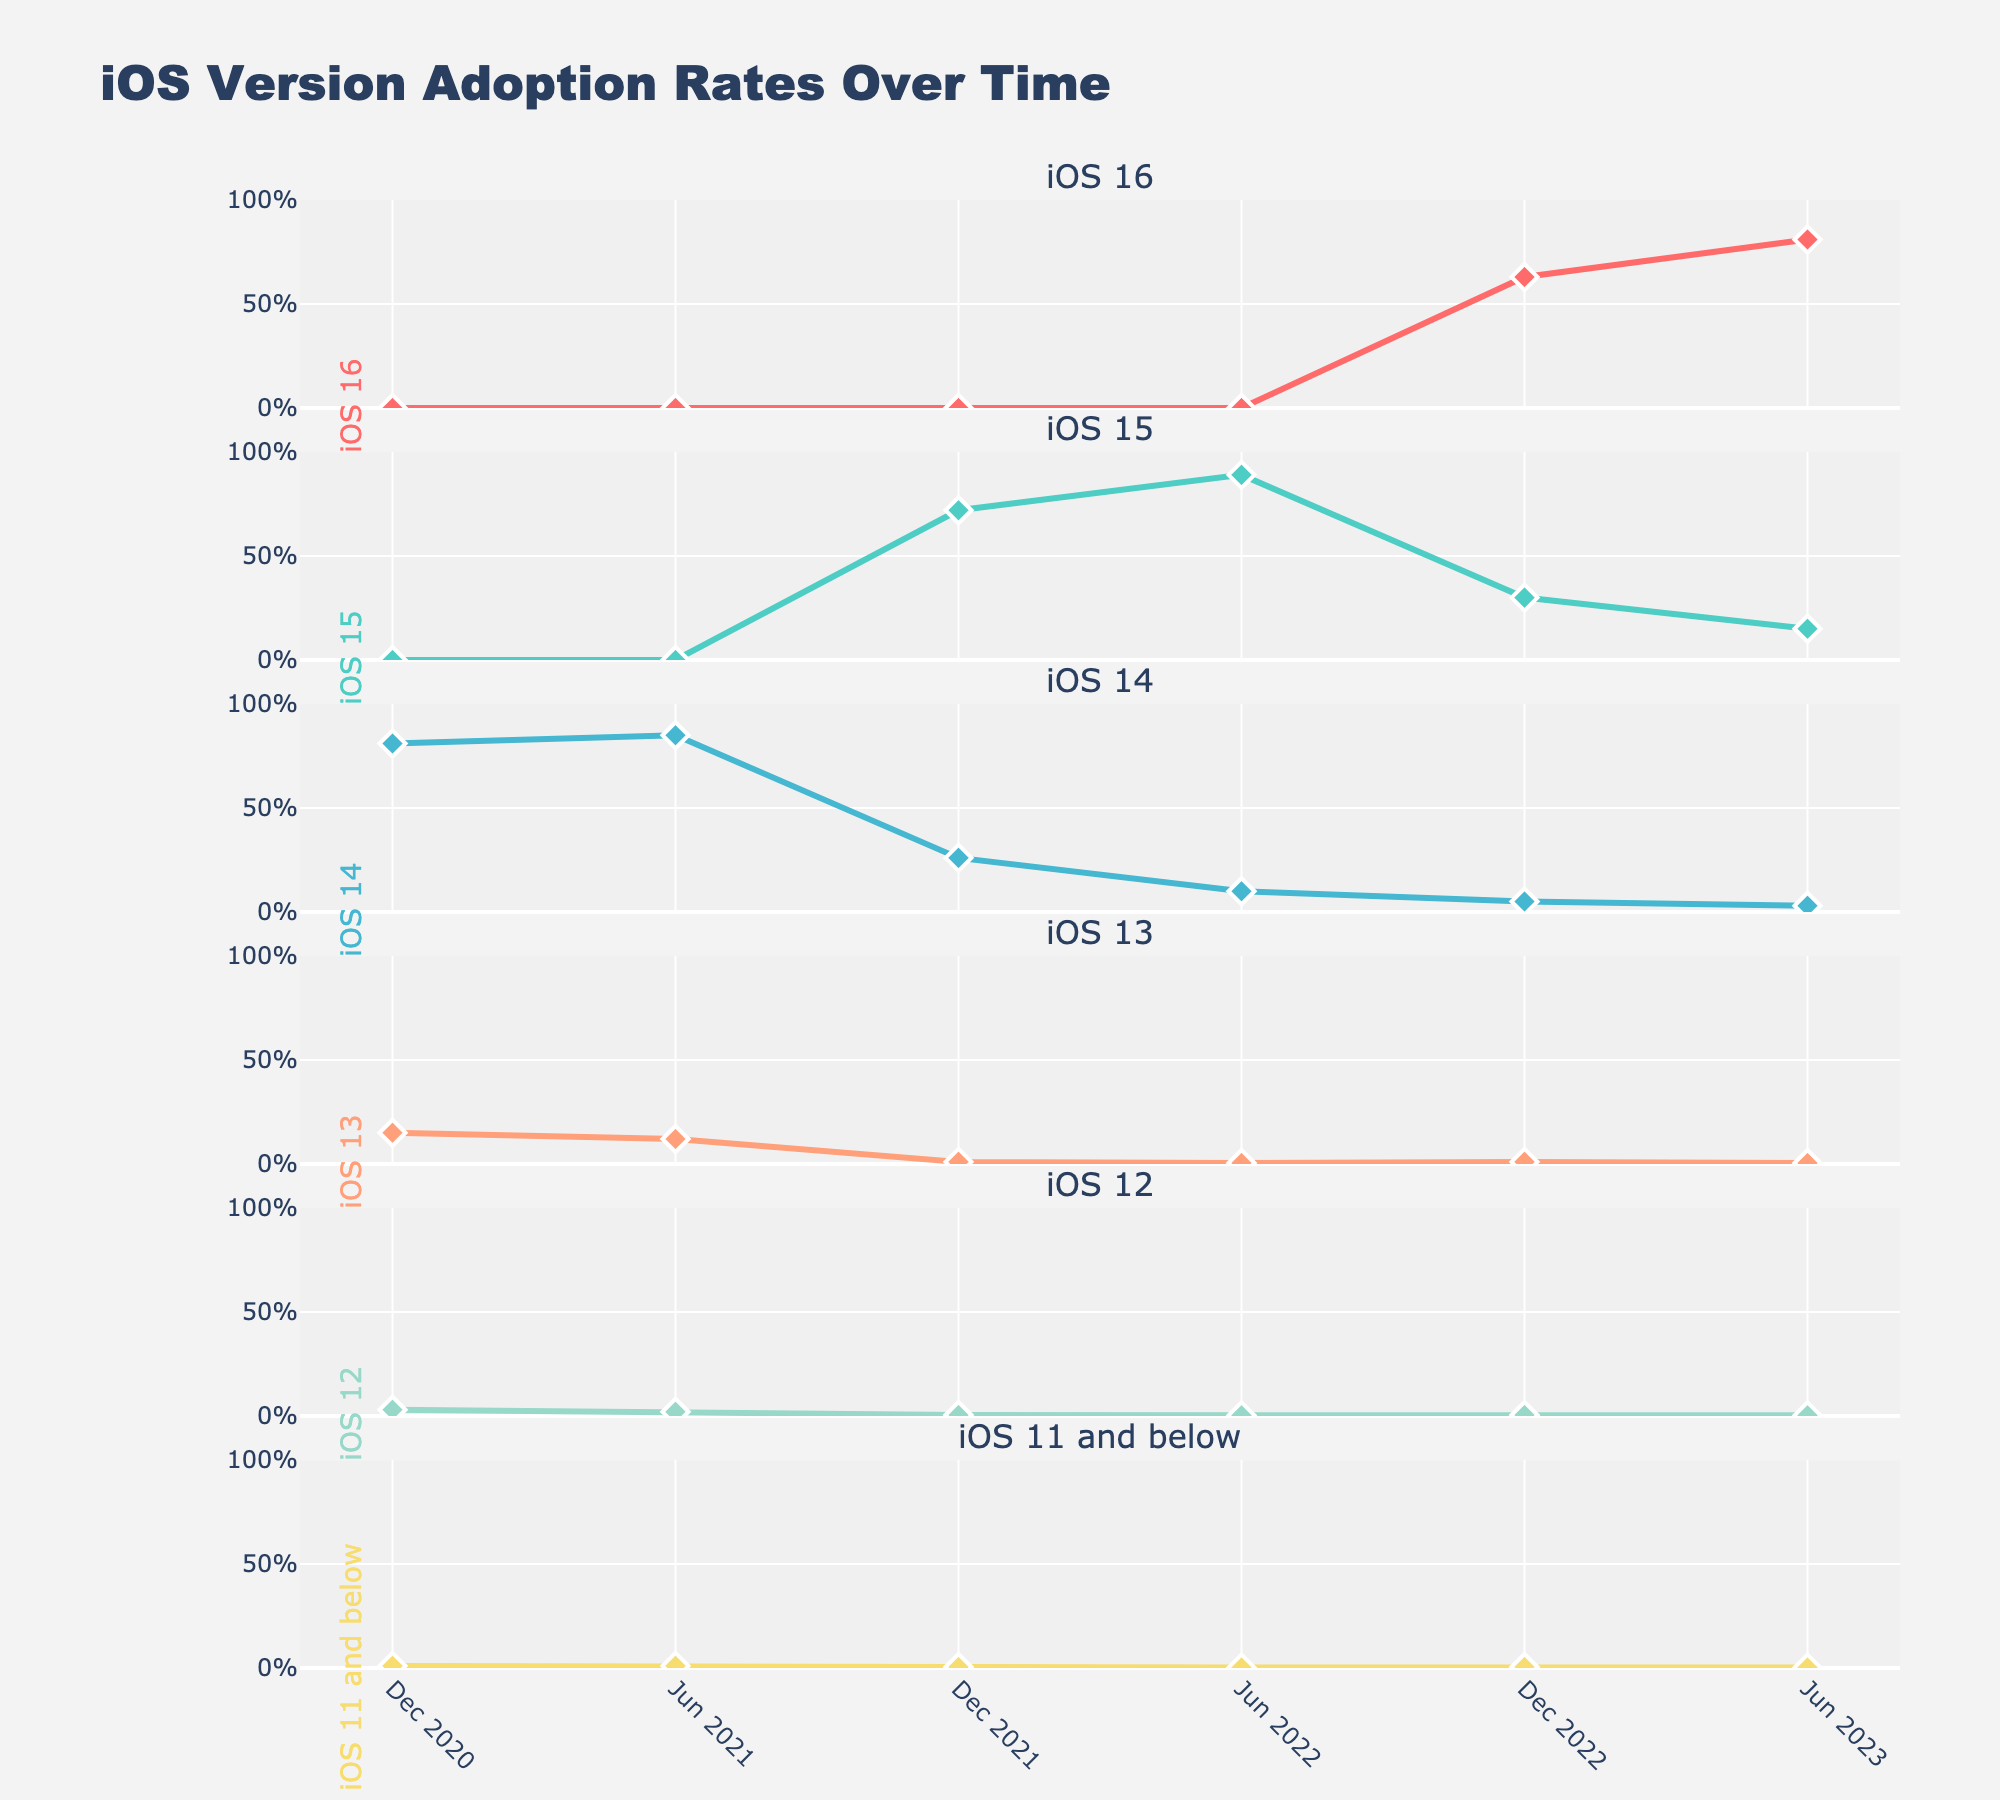what is the title of the figure? The title of the figure is displayed at the top and it reads "Women's Suffrage Movement Progress".
Answer: Women's Suffrage Movement Progress How many vertical subplots are there in the figure? The figure contains one subplot for each country, and there are five countries listed: USA, UK, New Zealand, Australia, and Canada. Thus, there are five vertical subplots.
Answer: 5 Which country reached 100% suffrage progress the earliest, and in which year? By looking at the plots, New Zealand reached 100% suffrage progress first. This happened around 1910.
Answer: New Zealand, 1910 How does the progress in women's suffrage compare between the USA and Canada by the year 1940? Examining the subplots at the year mark 1940, we see that the USA had already achieved 100% by 1920, while Canada only reached 100% by 1940.
Answer: USA reached 100% by 1920, Canada by 1940 What is the pattern of suffrage progress in the UK from 1890 to 1960? From 1890-1910, the UK had 0% progress. By 1930, the UK reached 100% and maintained this progress till 1960.
Answer: Started at 0%, reached 100% by 1930, stayed till 1960 Compare the suffrage progress growth rate of Australia and Canada between 1910 and 1930. Australia went from 0% in 1910 to 100% in 1920, a very rapid growth. Canada went from 0% in 1910 to 0% in 1930, indicating no growth in that period.
Answer: Australia had rapid growth (0% to 100%), Canada had no growth (0%) In which decade did Canada see any progress in women's suffrage? From examining the subplots, it is evident that Canada saw its first and only significant progress in suffrage from 1930 to 1940, reaching 100%.
Answer: 1930 to 1940 What percentage of suffrage progress did the USA achieve by 1900? Looking at the USA subplot in the year 1900, the suffrage progress was at 4%.
Answer: 4% Which country shows a star marker at each data point and what color is the line used for this country? Each subplot uses a star marker, but we note each country by color: the UK subplot has a line in turquoise color.
Answer: UK, turquoise 